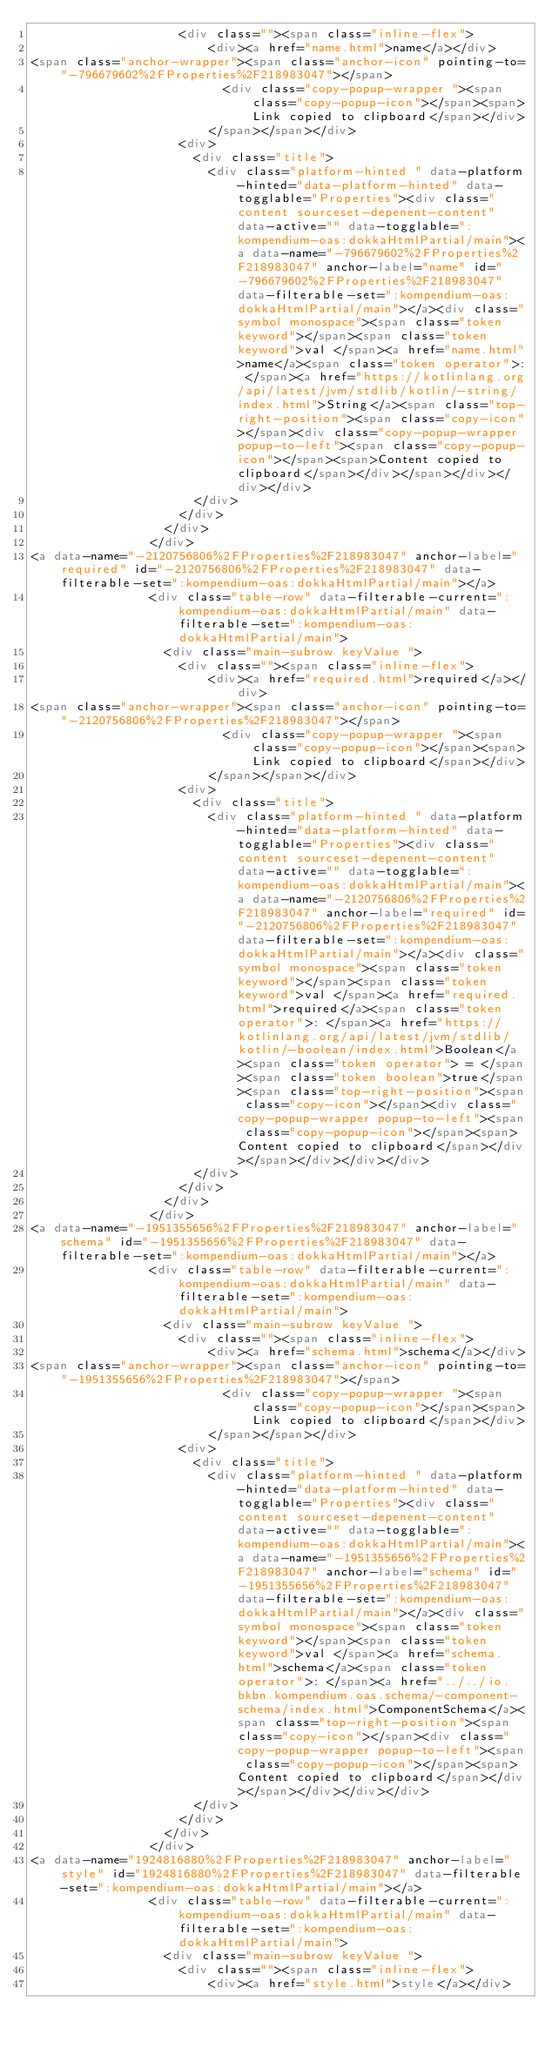Convert code to text. <code><loc_0><loc_0><loc_500><loc_500><_HTML_>                    <div class=""><span class="inline-flex">
                        <div><a href="name.html">name</a></div>
<span class="anchor-wrapper"><span class="anchor-icon" pointing-to="-796679602%2FProperties%2F218983047"></span>
                          <div class="copy-popup-wrapper "><span class="copy-popup-icon"></span><span>Link copied to clipboard</span></div>
                        </span></span></div>
                    <div>
                      <div class="title">
                        <div class="platform-hinted " data-platform-hinted="data-platform-hinted" data-togglable="Properties"><div class="content sourceset-depenent-content" data-active="" data-togglable=":kompendium-oas:dokkaHtmlPartial/main"><a data-name="-796679602%2FProperties%2F218983047" anchor-label="name" id="-796679602%2FProperties%2F218983047" data-filterable-set=":kompendium-oas:dokkaHtmlPartial/main"></a><div class="symbol monospace"><span class="token keyword"></span><span class="token keyword">val </span><a href="name.html">name</a><span class="token operator">: </span><a href="https://kotlinlang.org/api/latest/jvm/stdlib/kotlin/-string/index.html">String</a><span class="top-right-position"><span class="copy-icon"></span><div class="copy-popup-wrapper popup-to-left"><span class="copy-popup-icon"></span><span>Content copied to clipboard</span></div></span></div></div></div>
                      </div>
                    </div>
                  </div>
                </div>
<a data-name="-2120756806%2FProperties%2F218983047" anchor-label="required" id="-2120756806%2FProperties%2F218983047" data-filterable-set=":kompendium-oas:dokkaHtmlPartial/main"></a>
                <div class="table-row" data-filterable-current=":kompendium-oas:dokkaHtmlPartial/main" data-filterable-set=":kompendium-oas:dokkaHtmlPartial/main">
                  <div class="main-subrow keyValue ">
                    <div class=""><span class="inline-flex">
                        <div><a href="required.html">required</a></div>
<span class="anchor-wrapper"><span class="anchor-icon" pointing-to="-2120756806%2FProperties%2F218983047"></span>
                          <div class="copy-popup-wrapper "><span class="copy-popup-icon"></span><span>Link copied to clipboard</span></div>
                        </span></span></div>
                    <div>
                      <div class="title">
                        <div class="platform-hinted " data-platform-hinted="data-platform-hinted" data-togglable="Properties"><div class="content sourceset-depenent-content" data-active="" data-togglable=":kompendium-oas:dokkaHtmlPartial/main"><a data-name="-2120756806%2FProperties%2F218983047" anchor-label="required" id="-2120756806%2FProperties%2F218983047" data-filterable-set=":kompendium-oas:dokkaHtmlPartial/main"></a><div class="symbol monospace"><span class="token keyword"></span><span class="token keyword">val </span><a href="required.html">required</a><span class="token operator">: </span><a href="https://kotlinlang.org/api/latest/jvm/stdlib/kotlin/-boolean/index.html">Boolean</a><span class="token operator"> = </span><span class="token boolean">true</span><span class="top-right-position"><span class="copy-icon"></span><div class="copy-popup-wrapper popup-to-left"><span class="copy-popup-icon"></span><span>Content copied to clipboard</span></div></span></div></div></div>
                      </div>
                    </div>
                  </div>
                </div>
<a data-name="-1951355656%2FProperties%2F218983047" anchor-label="schema" id="-1951355656%2FProperties%2F218983047" data-filterable-set=":kompendium-oas:dokkaHtmlPartial/main"></a>
                <div class="table-row" data-filterable-current=":kompendium-oas:dokkaHtmlPartial/main" data-filterable-set=":kompendium-oas:dokkaHtmlPartial/main">
                  <div class="main-subrow keyValue ">
                    <div class=""><span class="inline-flex">
                        <div><a href="schema.html">schema</a></div>
<span class="anchor-wrapper"><span class="anchor-icon" pointing-to="-1951355656%2FProperties%2F218983047"></span>
                          <div class="copy-popup-wrapper "><span class="copy-popup-icon"></span><span>Link copied to clipboard</span></div>
                        </span></span></div>
                    <div>
                      <div class="title">
                        <div class="platform-hinted " data-platform-hinted="data-platform-hinted" data-togglable="Properties"><div class="content sourceset-depenent-content" data-active="" data-togglable=":kompendium-oas:dokkaHtmlPartial/main"><a data-name="-1951355656%2FProperties%2F218983047" anchor-label="schema" id="-1951355656%2FProperties%2F218983047" data-filterable-set=":kompendium-oas:dokkaHtmlPartial/main"></a><div class="symbol monospace"><span class="token keyword"></span><span class="token keyword">val </span><a href="schema.html">schema</a><span class="token operator">: </span><a href="../../io.bkbn.kompendium.oas.schema/-component-schema/index.html">ComponentSchema</a><span class="top-right-position"><span class="copy-icon"></span><div class="copy-popup-wrapper popup-to-left"><span class="copy-popup-icon"></span><span>Content copied to clipboard</span></div></span></div></div></div>
                      </div>
                    </div>
                  </div>
                </div>
<a data-name="1924816880%2FProperties%2F218983047" anchor-label="style" id="1924816880%2FProperties%2F218983047" data-filterable-set=":kompendium-oas:dokkaHtmlPartial/main"></a>
                <div class="table-row" data-filterable-current=":kompendium-oas:dokkaHtmlPartial/main" data-filterable-set=":kompendium-oas:dokkaHtmlPartial/main">
                  <div class="main-subrow keyValue ">
                    <div class=""><span class="inline-flex">
                        <div><a href="style.html">style</a></div></code> 